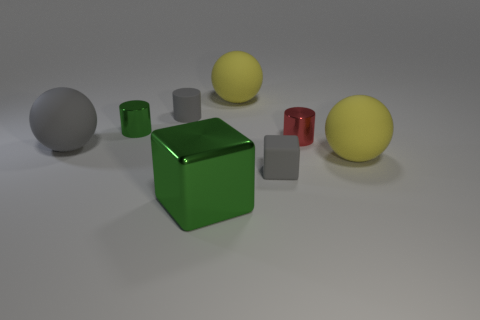Is the metallic block the same size as the red metal object?
Give a very brief answer. No. How many objects are rubber cubes or small shiny balls?
Ensure brevity in your answer.  1. How big is the green block in front of the big yellow rubber object that is to the left of the rubber cube?
Offer a very short reply. Large. How big is the red metallic cylinder?
Offer a very short reply. Small. What is the shape of the big rubber thing that is both left of the gray block and to the right of the big gray ball?
Your answer should be very brief. Sphere. There is a rubber thing that is the same shape as the red metallic object; what color is it?
Ensure brevity in your answer.  Gray. How many objects are shiny things that are behind the green metal cube or small matte things right of the large green cube?
Provide a succinct answer. 3. What shape is the red thing?
Your answer should be very brief. Cylinder. What shape is the large rubber thing that is the same color as the rubber block?
Give a very brief answer. Sphere. What number of large green balls are the same material as the tiny green cylinder?
Ensure brevity in your answer.  0. 